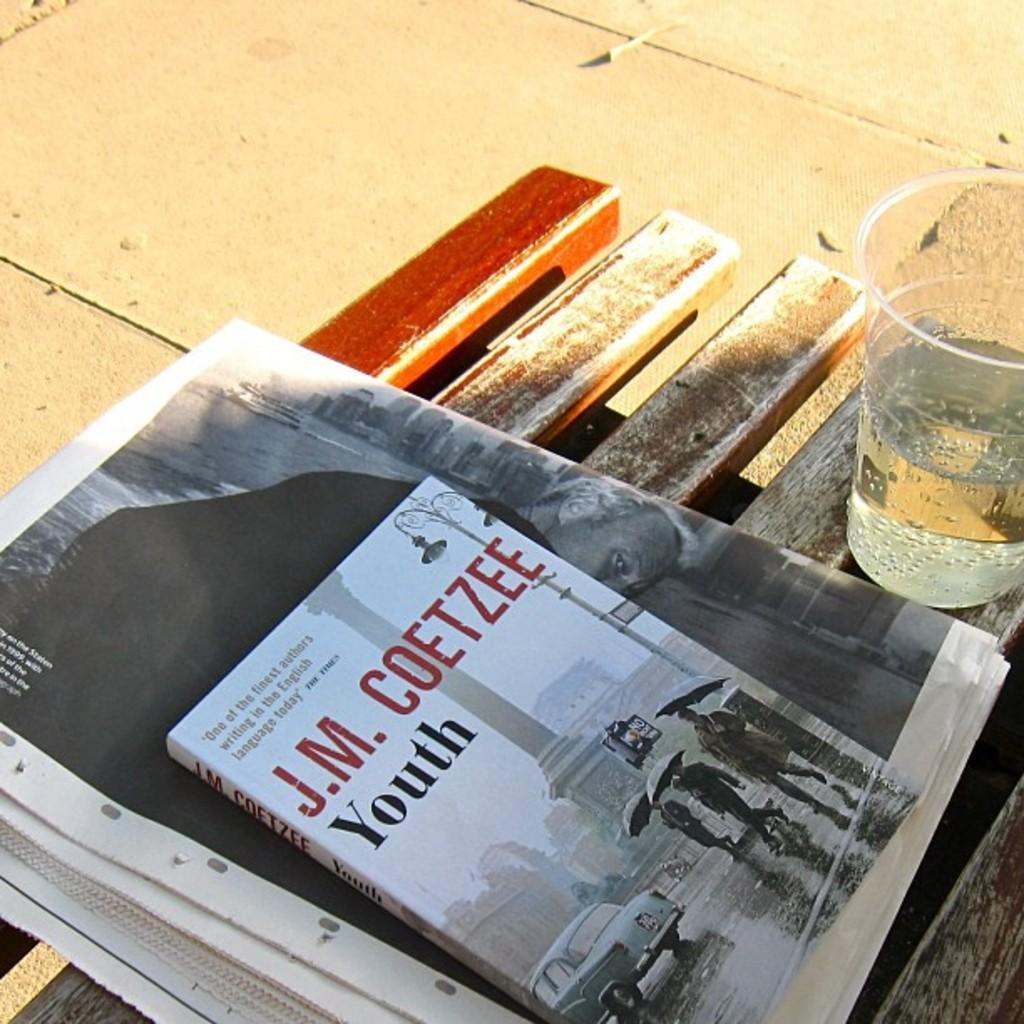<image>
Create a compact narrative representing the image presented. A glass of sparkling water next to a newspaper with the book Youth by J.M. Coetzee on a wooden slat bench. 